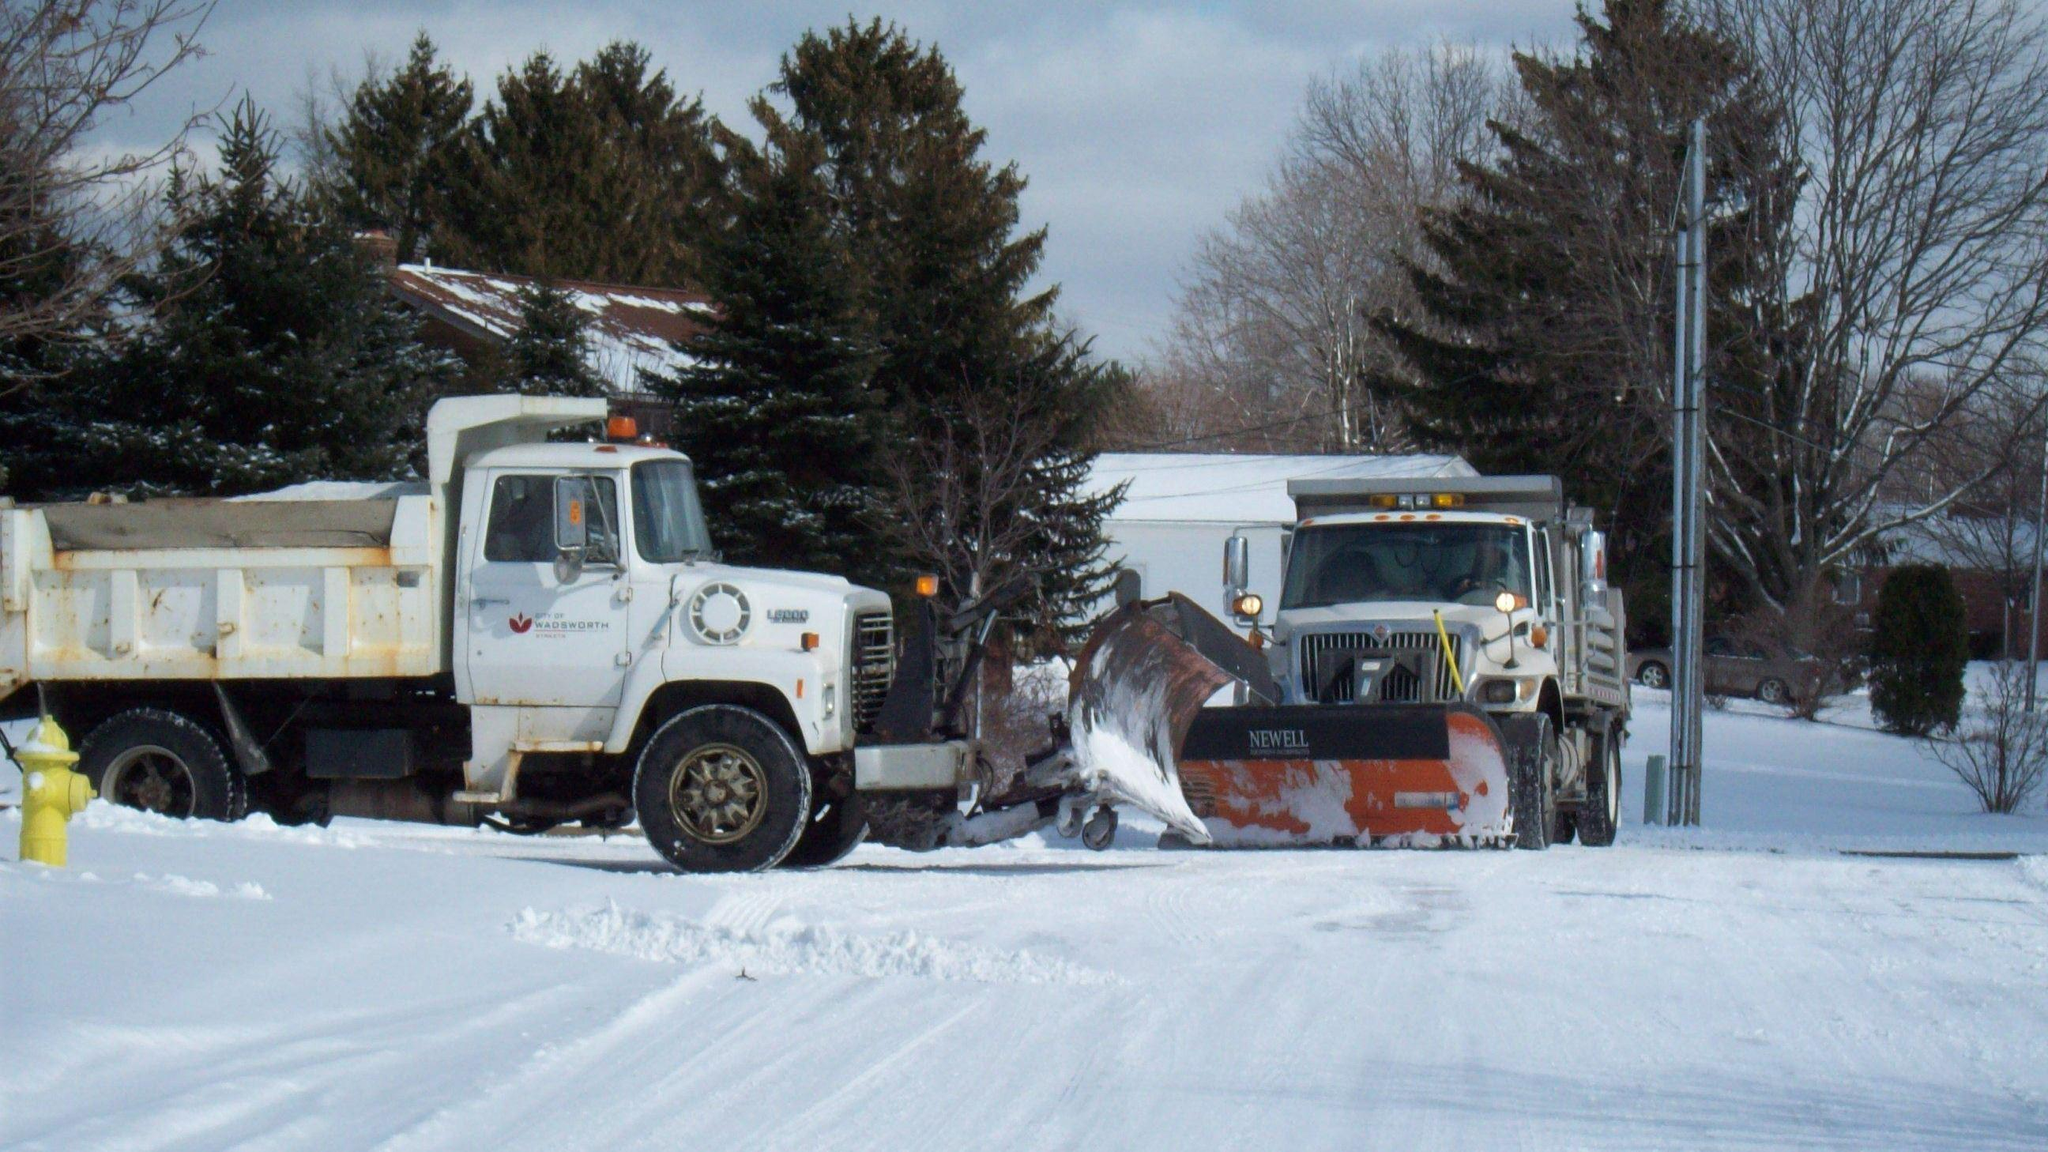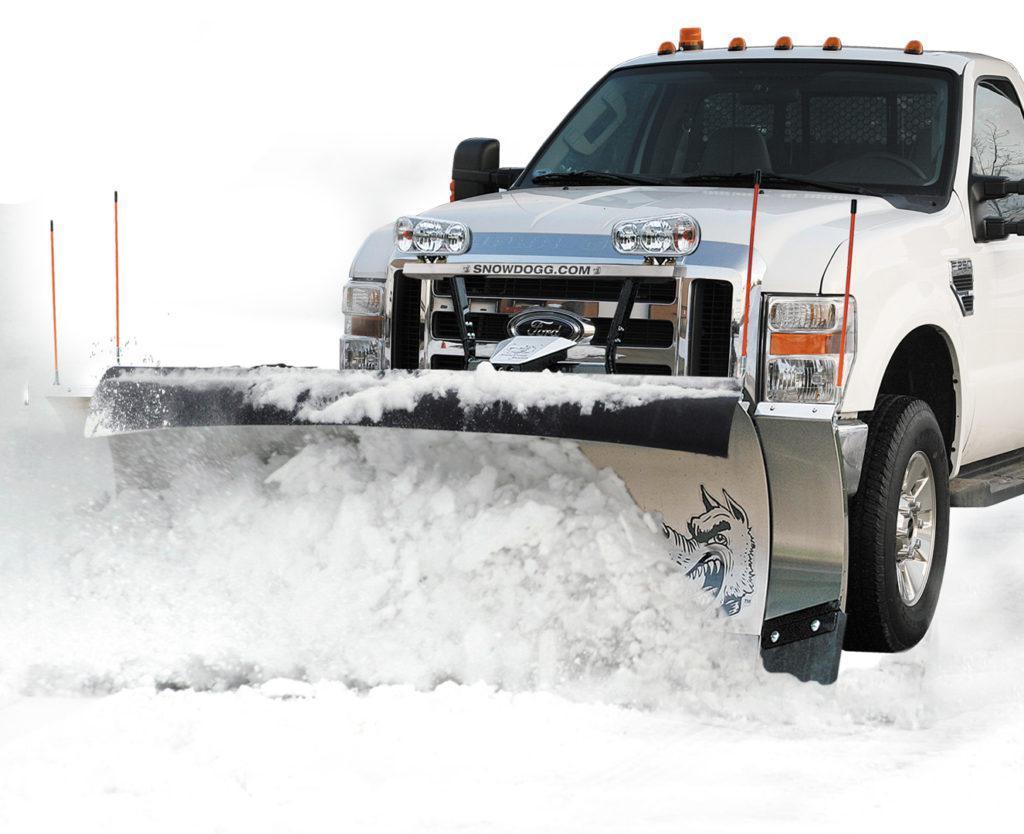The first image is the image on the left, the second image is the image on the right. Considering the images on both sides, is "The left and right image contains a total of three trucks." valid? Answer yes or no. Yes. The first image is the image on the left, the second image is the image on the right. Given the left and right images, does the statement "One of the images shows two plows and the other shows only one plow." hold true? Answer yes or no. Yes. 